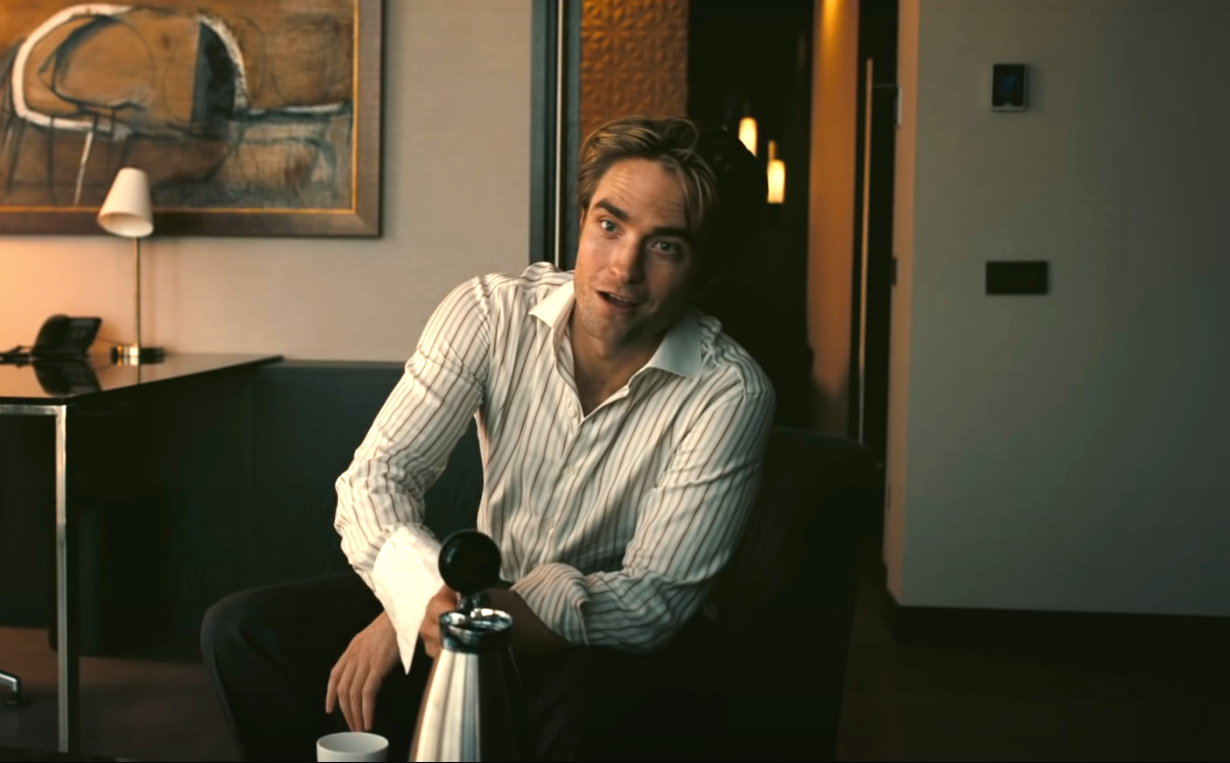If this image could talk, what story would it tell? If this image could talk, it might tell the story of a man who has just received life-changing news. Perhaps he has reconnected with a long-lost friend or learned about a new opportunity that could change his career. The silver pitcher in his hands might symbolize purity and clarity, hinting that this news has brought a sense of relief and a fresh perspective. The peaceful setting reflects his inner tranquility and the excitement of new beginnings, painting a picture of a man ready to embark on a new journey with renewed hope and confidence. 